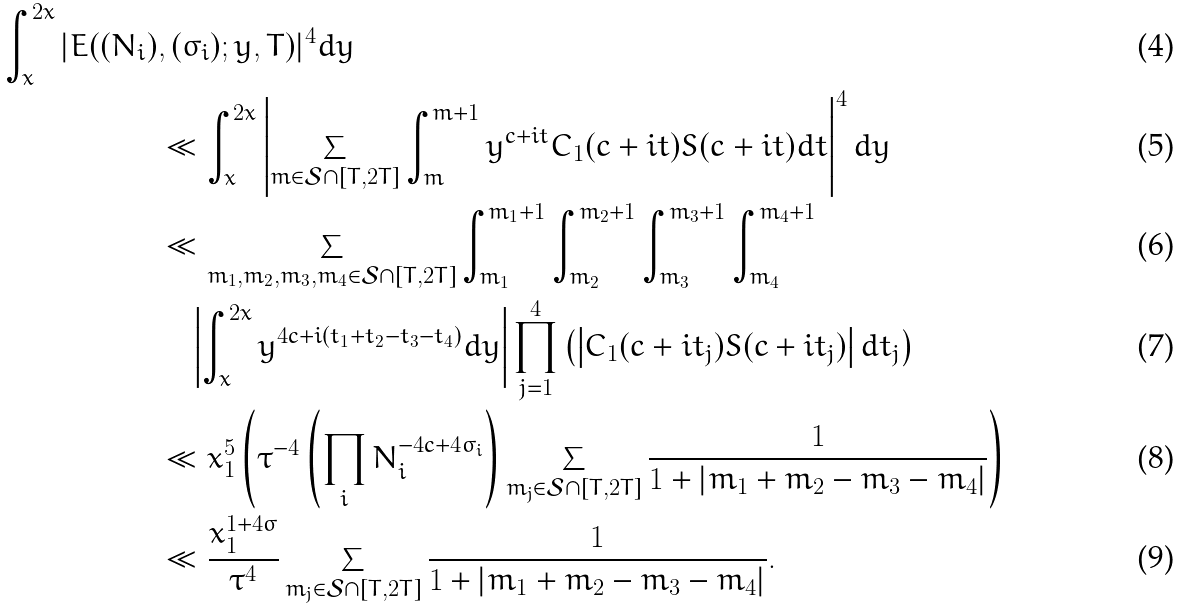Convert formula to latex. <formula><loc_0><loc_0><loc_500><loc_500>\int _ { x } ^ { 2 x } | E ( ( N _ { i } ) & , ( \sigma _ { i } ) ; y , T ) | ^ { 4 } d y \\ & \ll \int _ { x } ^ { 2 x } \left | \sum _ { m \in \mathcal { S } \cap [ T , 2 T ] } \int _ { m } ^ { m + 1 } y ^ { c + i t } C _ { 1 } ( c + i t ) S ( c + i t ) d t \right | ^ { 4 } d y \\ & \ll \sum _ { m _ { 1 } , m _ { 2 } , m _ { 3 } , m _ { 4 } \in \mathcal { S } \cap [ T , 2 T ] } \int _ { m _ { 1 } } ^ { m _ { 1 } + 1 } \int _ { m _ { 2 } } ^ { m _ { 2 } + 1 } \int _ { m _ { 3 } } ^ { m _ { 3 } + 1 } \int _ { m _ { 4 } } ^ { m _ { 4 } + 1 } \\ & \quad \left | \int _ { x } ^ { 2 x } y ^ { 4 c + i ( t _ { 1 } + t _ { 2 } - t _ { 3 } - t _ { 4 } ) } d y \right | \prod _ { j = 1 } ^ { 4 } \left ( \left | C _ { 1 } ( c + i t _ { j } ) S ( c + i t _ { j } ) \right | d t _ { j } \right ) \\ & \ll x _ { 1 } ^ { 5 } \left ( \tau ^ { - 4 } \left ( \prod _ { i } N _ { i } ^ { - 4 c + 4 \sigma _ { i } } \right ) \sum _ { m _ { j } \in \mathcal { S } \cap [ T , 2 T ] } \frac { 1 } { 1 + | m _ { 1 } + m _ { 2 } - m _ { 3 } - m _ { 4 } | } \right ) \\ & \ll \frac { x _ { 1 } ^ { 1 + 4 \sigma } } { \tau ^ { 4 } } \sum _ { m _ { j } \in \mathcal { S } \cap [ T , 2 T ] } \frac { 1 } { 1 + | m _ { 1 } + m _ { 2 } - m _ { 3 } - m _ { 4 } | } .</formula> 